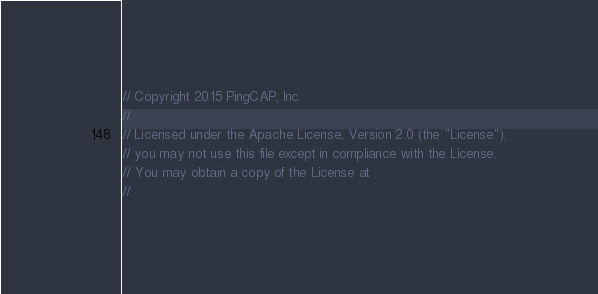Convert code to text. <code><loc_0><loc_0><loc_500><loc_500><_Go_>// Copyright 2015 PingCAP, Inc.
//
// Licensed under the Apache License, Version 2.0 (the "License");
// you may not use this file except in compliance with the License.
// You may obtain a copy of the License at
//</code> 